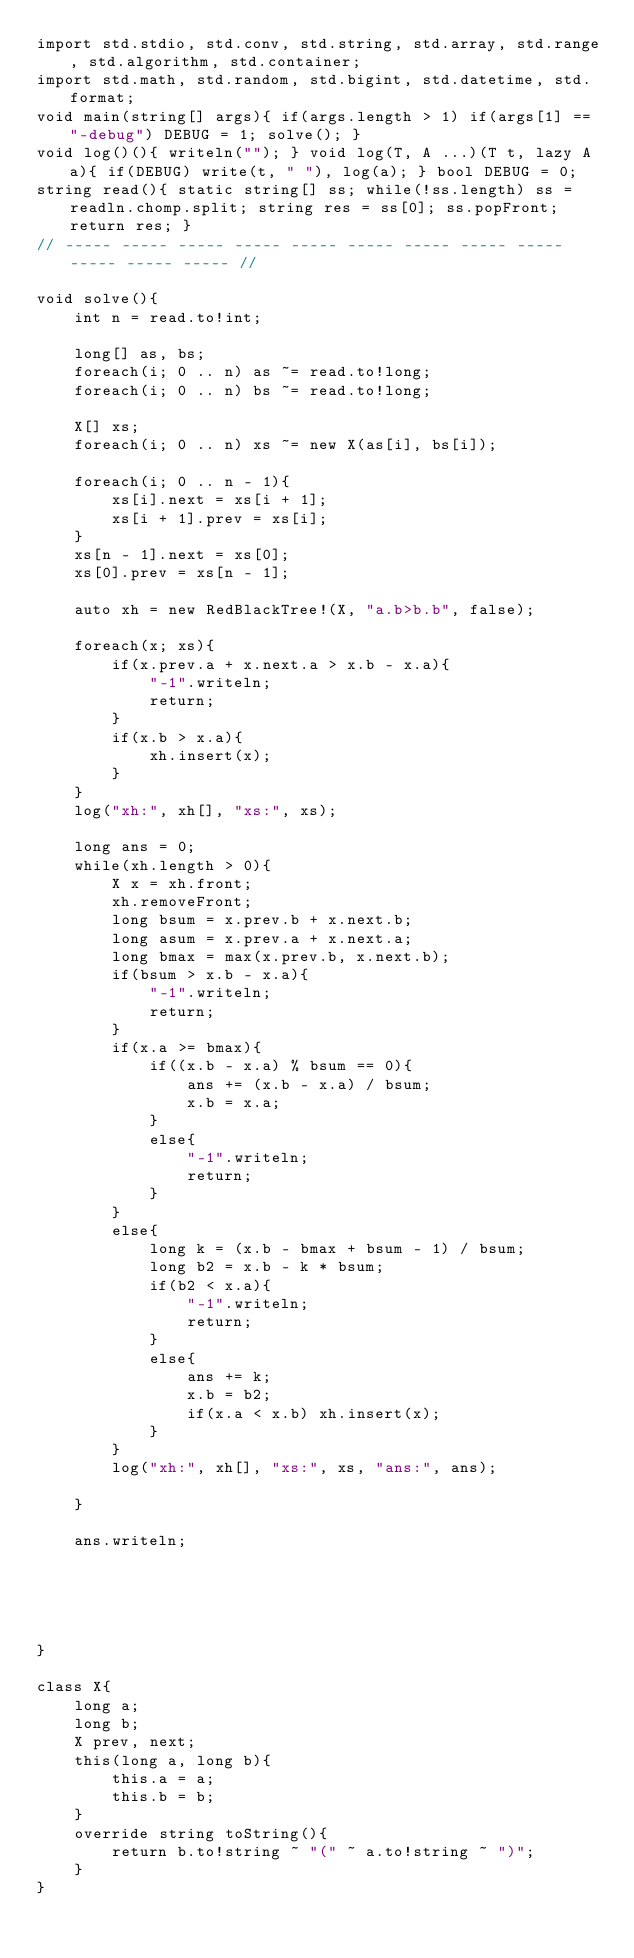Convert code to text. <code><loc_0><loc_0><loc_500><loc_500><_D_>import std.stdio, std.conv, std.string, std.array, std.range, std.algorithm, std.container;
import std.math, std.random, std.bigint, std.datetime, std.format;
void main(string[] args){ if(args.length > 1) if(args[1] == "-debug") DEBUG = 1; solve(); }
void log()(){ writeln(""); } void log(T, A ...)(T t, lazy A a){ if(DEBUG) write(t, " "), log(a); } bool DEBUG = 0; 
string read(){ static string[] ss; while(!ss.length) ss = readln.chomp.split; string res = ss[0]; ss.popFront; return res; }
// ----- ----- ----- ----- ----- ----- ----- ----- ----- ----- ----- ----- //

void solve(){
	int n = read.to!int;
	
	long[] as, bs;
	foreach(i; 0 .. n) as ~= read.to!long;
	foreach(i; 0 .. n) bs ~= read.to!long;
	
	X[] xs;
	foreach(i; 0 .. n) xs ~= new X(as[i], bs[i]);
	
	foreach(i; 0 .. n - 1){
		xs[i].next = xs[i + 1];
		xs[i + 1].prev = xs[i];
	}
	xs[n - 1].next = xs[0];
	xs[0].prev = xs[n - 1];
	
	auto xh = new RedBlackTree!(X, "a.b>b.b", false);
	
	foreach(x; xs){
		if(x.prev.a + x.next.a > x.b - x.a){
			"-1".writeln;
			return;
		}
		if(x.b > x.a){
			xh.insert(x);
		}
	}
	log("xh:", xh[], "xs:", xs);
	
	long ans = 0;
	while(xh.length > 0){
		X x = xh.front;
		xh.removeFront;
		long bsum = x.prev.b + x.next.b;
		long asum = x.prev.a + x.next.a;
		long bmax = max(x.prev.b, x.next.b);
		if(bsum > x.b - x.a){
			"-1".writeln;
			return;
		}
		if(x.a >= bmax){
			if((x.b - x.a) % bsum == 0){
				ans += (x.b - x.a) / bsum;
				x.b = x.a;
			}
			else{
				"-1".writeln;
				return;
			}
		}
		else{
			long k = (x.b - bmax + bsum - 1) / bsum;
			long b2 = x.b - k * bsum;
			if(b2 < x.a){
				"-1".writeln;
				return;
			}
			else{
				ans += k;
				x.b = b2;
				if(x.a < x.b) xh.insert(x);
			}
		}
		log("xh:", xh[], "xs:", xs, "ans:", ans);
		
	}
	
	ans.writeln;
	
	
	
	

}

class X{
	long a;
	long b;
	X prev, next;
	this(long a, long b){
		this.a = a;
		this.b = b;
	}
	override string toString(){
		return b.to!string ~ "(" ~ a.to!string ~ ")";
	}
}
</code> 